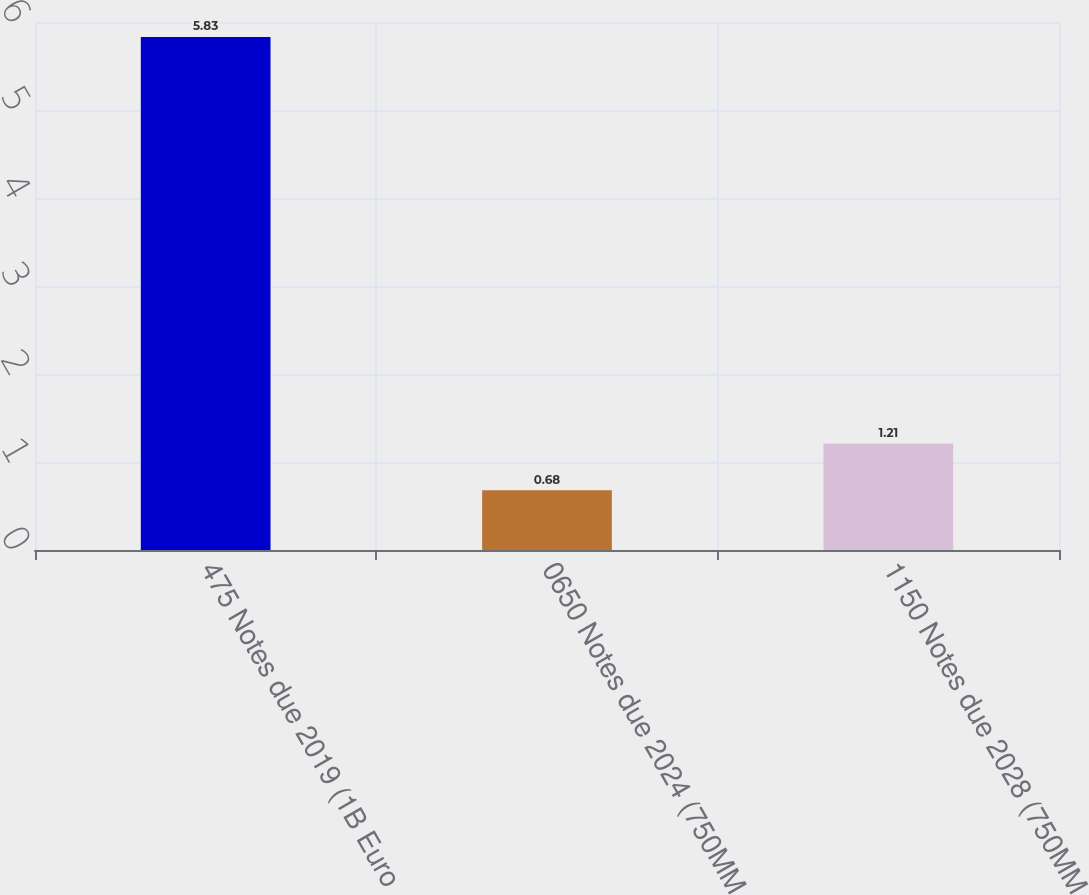Convert chart. <chart><loc_0><loc_0><loc_500><loc_500><bar_chart><fcel>475 Notes due 2019 (1B Euro<fcel>0650 Notes due 2024 (750MM<fcel>1150 Notes due 2028 (750MM<nl><fcel>5.83<fcel>0.68<fcel>1.21<nl></chart> 